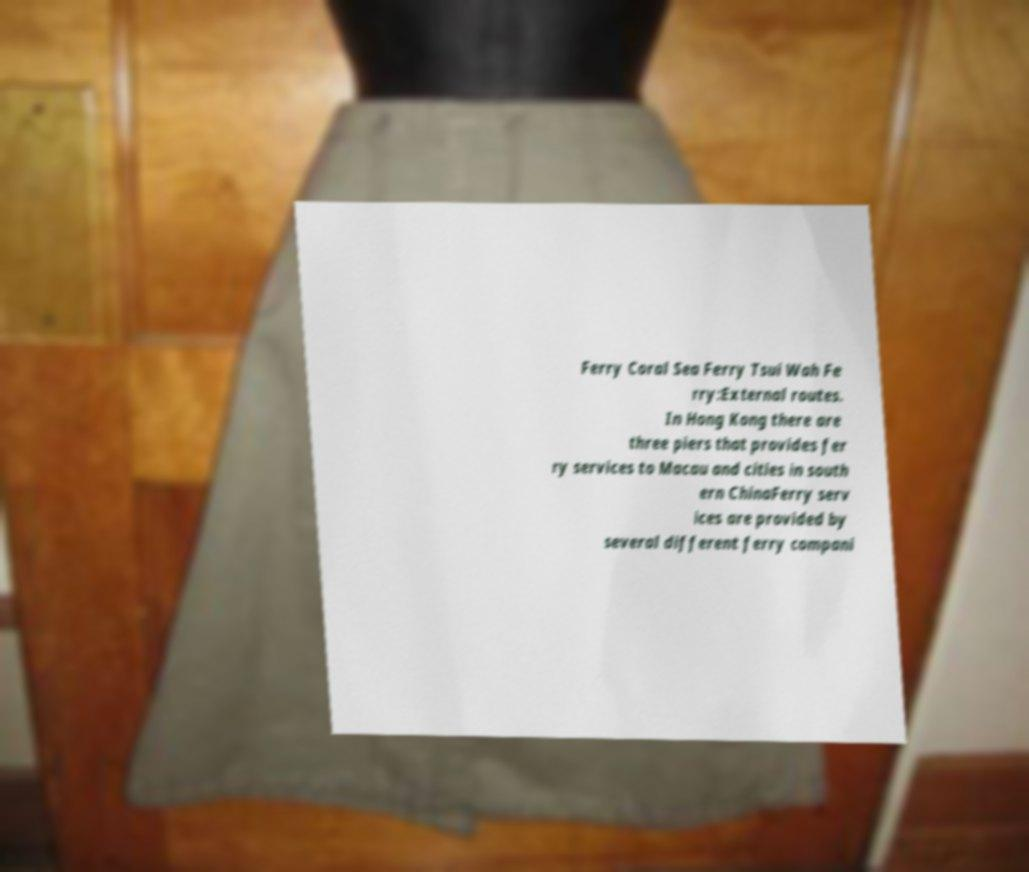I need the written content from this picture converted into text. Can you do that? Ferry Coral Sea Ferry Tsui Wah Fe rry:External routes. In Hong Kong there are three piers that provides fer ry services to Macau and cities in south ern ChinaFerry serv ices are provided by several different ferry compani 